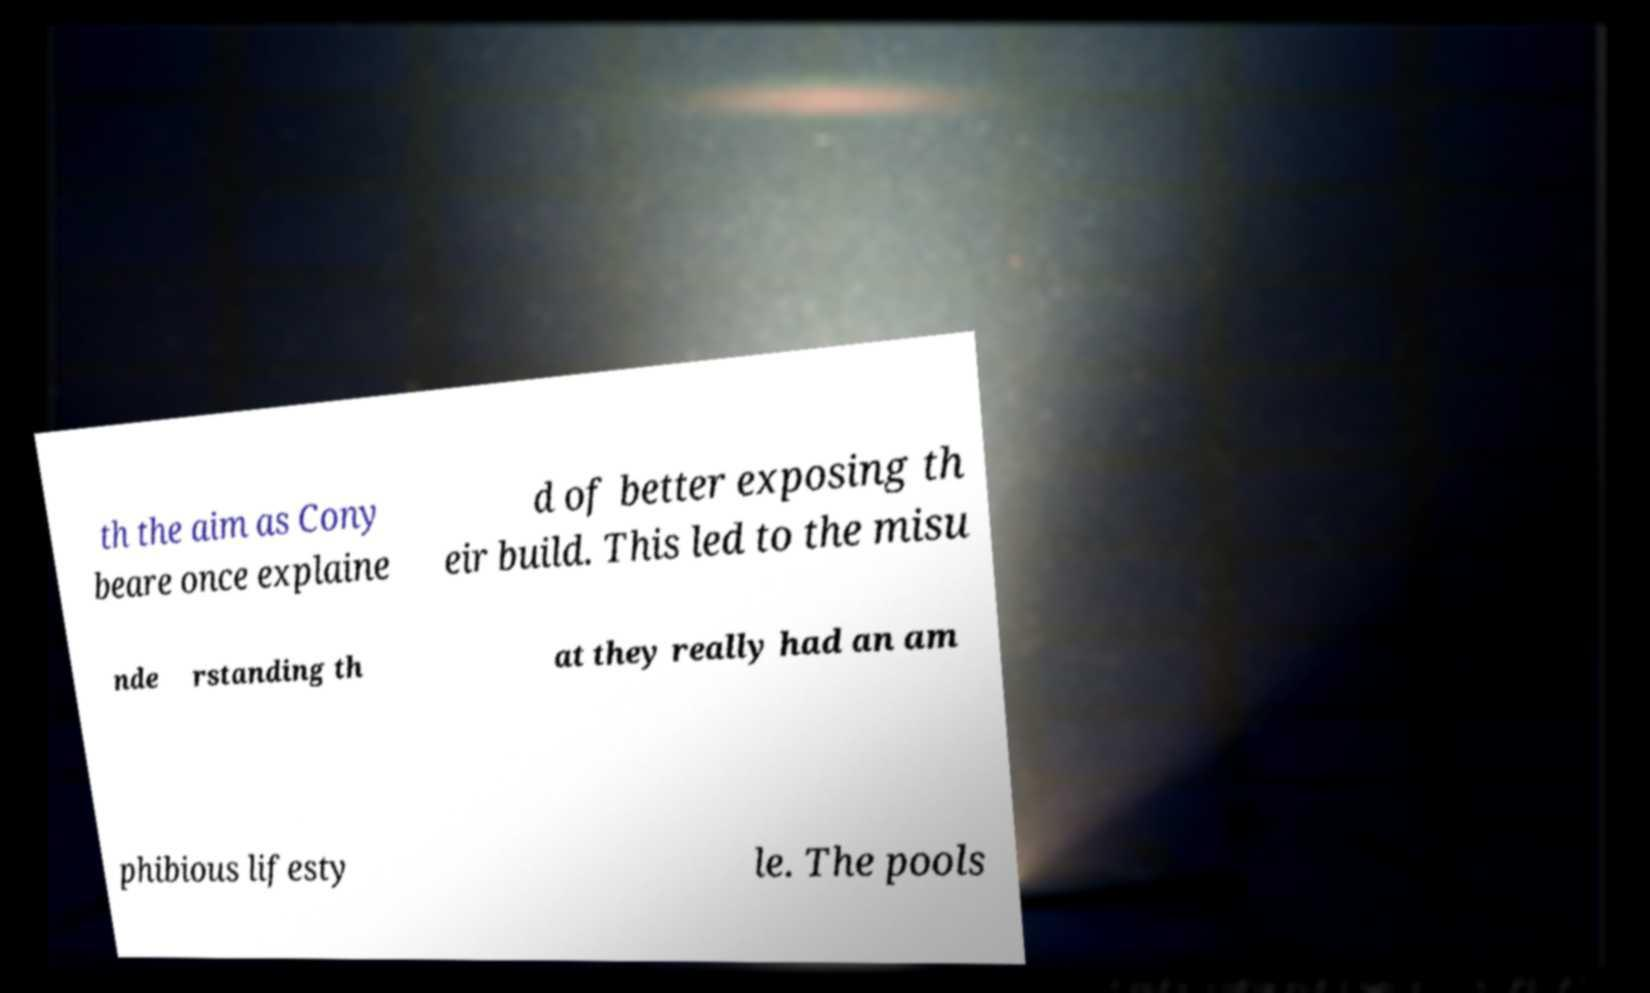There's text embedded in this image that I need extracted. Can you transcribe it verbatim? th the aim as Cony beare once explaine d of better exposing th eir build. This led to the misu nde rstanding th at they really had an am phibious lifesty le. The pools 